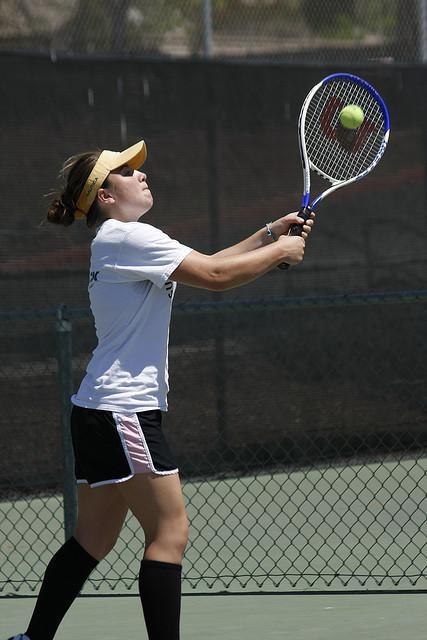What is the most common tennis racquet string material? nylon 